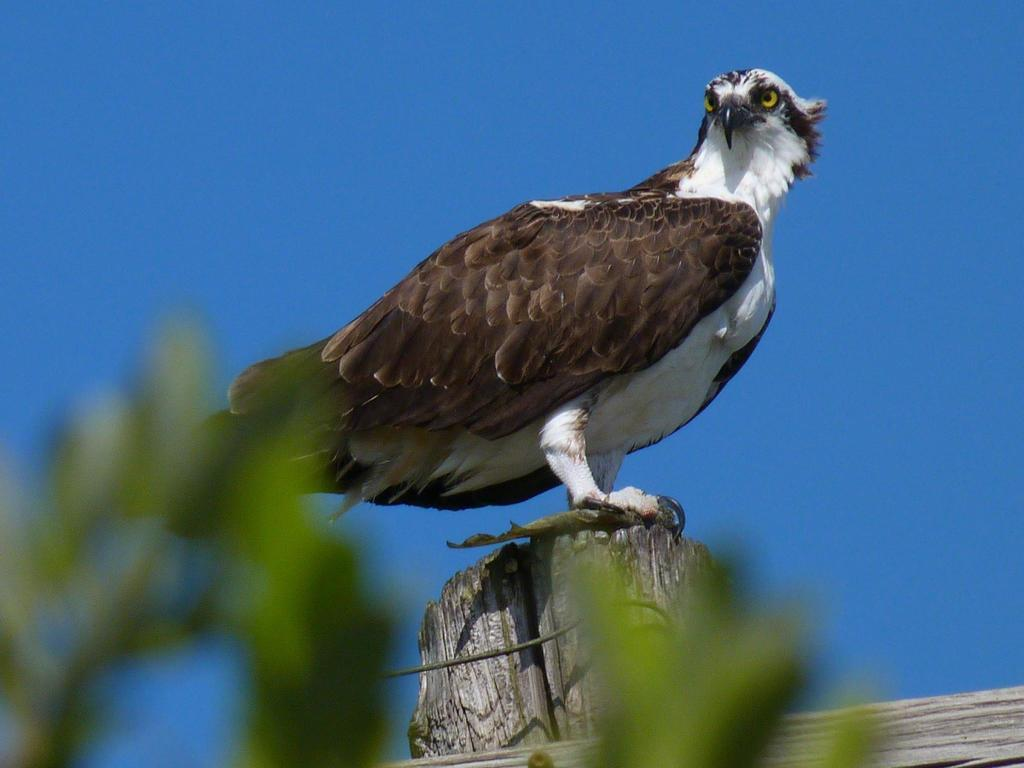What type of bird is in the image? There is an osprey bird in the image. What is the bird standing on? The bird is standing on wood. What type of vegetation is at the bottom of the image? There are leaves at the bottom of the image. What is visible at the top of the image? The sky is visible at the top of the image. How many sheep are present in the room in the image? There are no sheep or rooms present in the image; it features an osprey bird standing on wood with leaves and sky visible. 